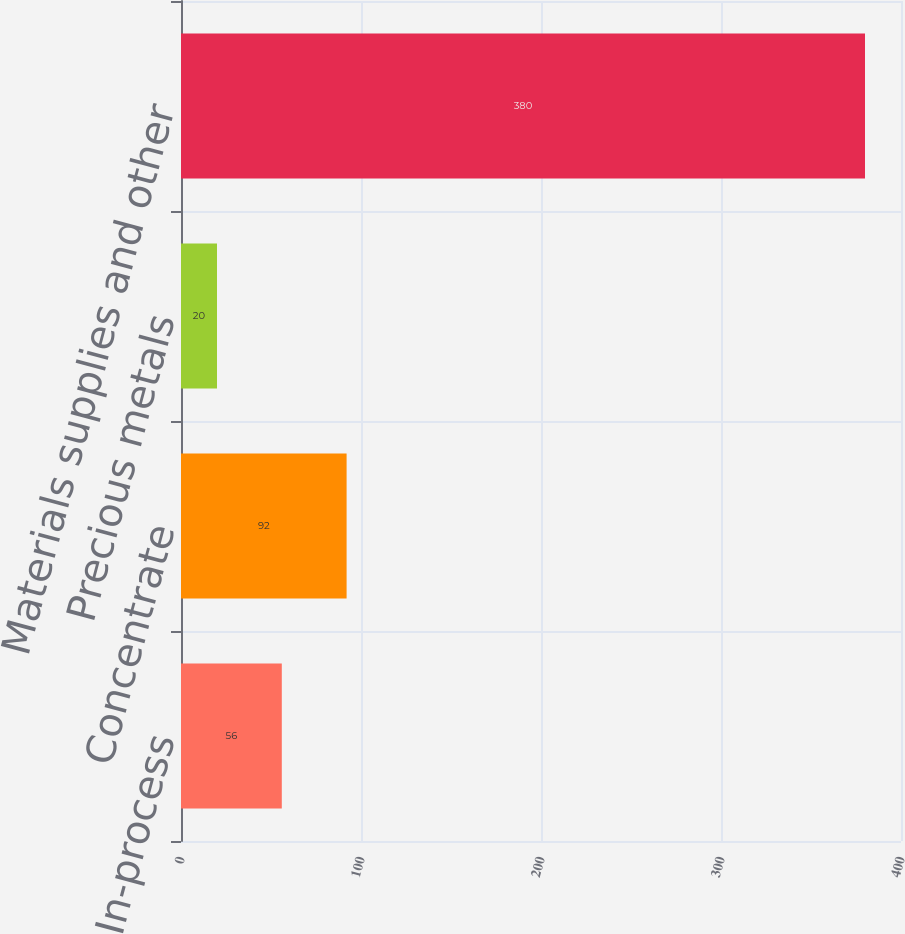<chart> <loc_0><loc_0><loc_500><loc_500><bar_chart><fcel>In-process<fcel>Concentrate<fcel>Precious metals<fcel>Materials supplies and other<nl><fcel>56<fcel>92<fcel>20<fcel>380<nl></chart> 